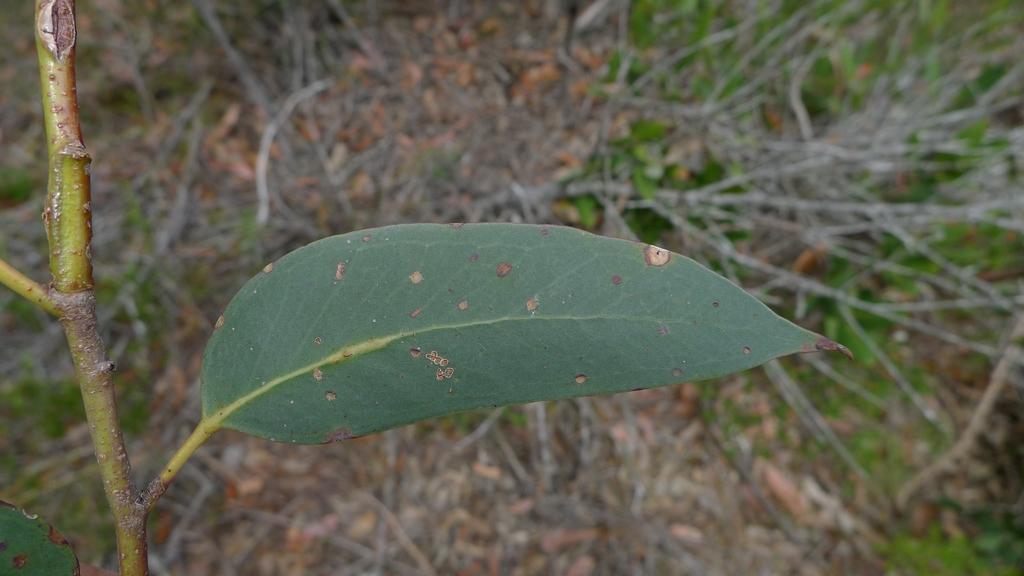How would you summarize this image in a sentence or two? In this image there is a stem with a leaf. At the bottom there are so many wooden sticks and dry leaves. On the leaf there are spots. 